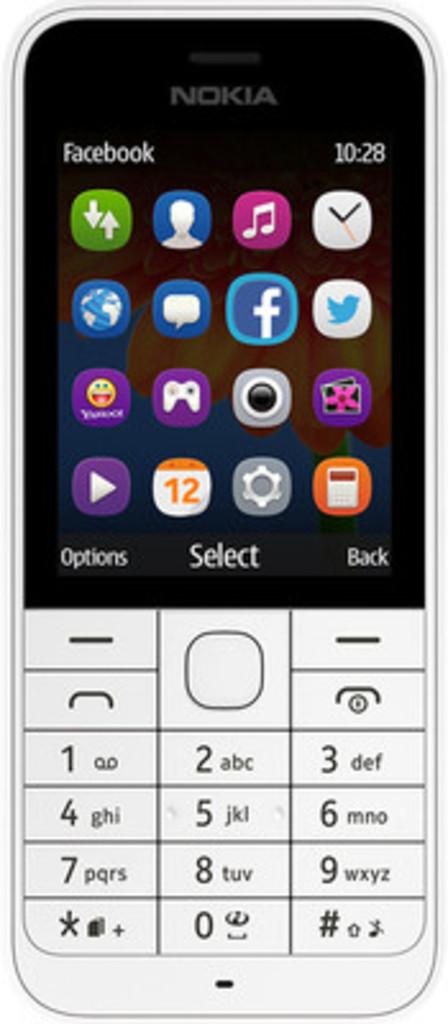What date is on the calender?
Offer a terse response. 12. 